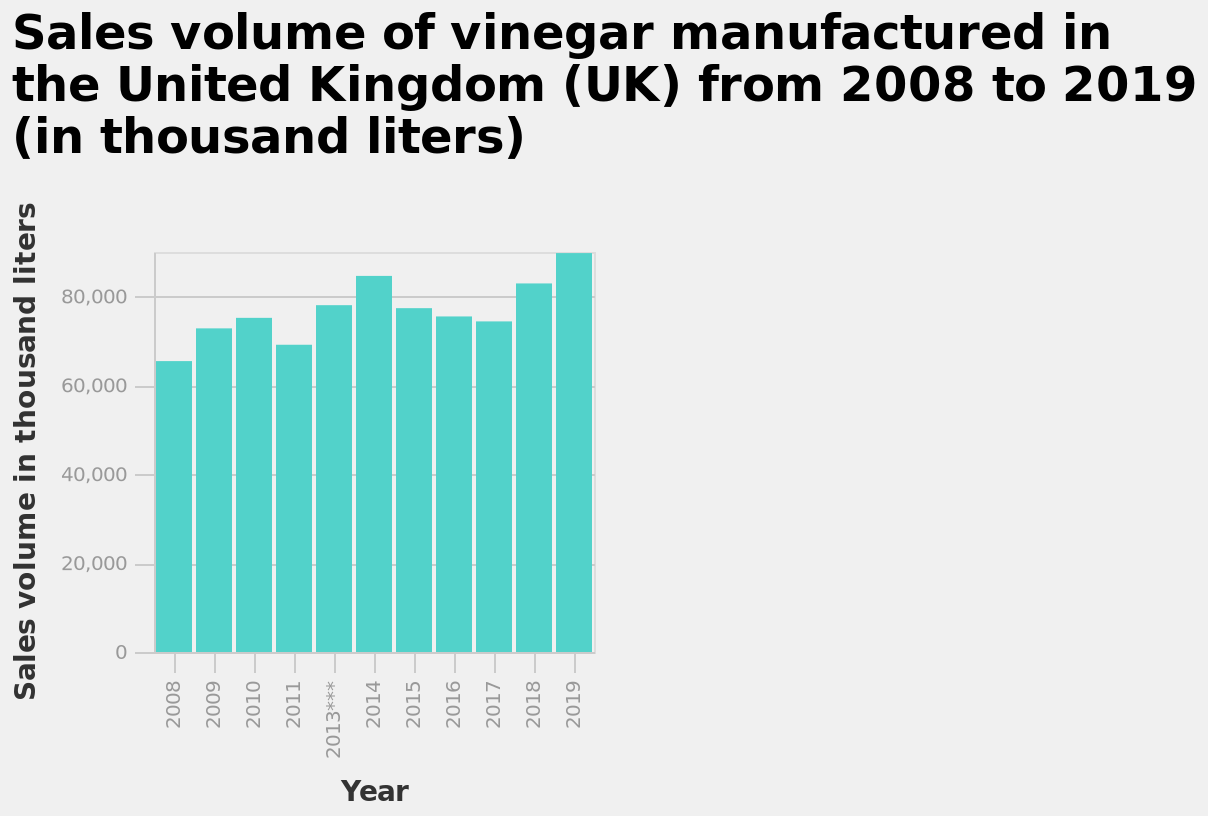<image>
What does the bar diagram represent?  The bar diagram represents the sales volume of vinegar manufactured in the United Kingdom (UK) from 2008 to 2019. In which year did the sales of vinegar reach their lowest level in the given period?  The year 2008 had the lowest sales level of vinegar between 2008 and 2019. What is shown on the x-axis of the bar diagram?  The x-axis of the bar diagram shows the years from 2008 to 2019. Is 2019 a notable year for vinegar sales? Yes, 2019 is a significant year for vinegar sales as it had the highest level of sales between 2008 and 2019. 